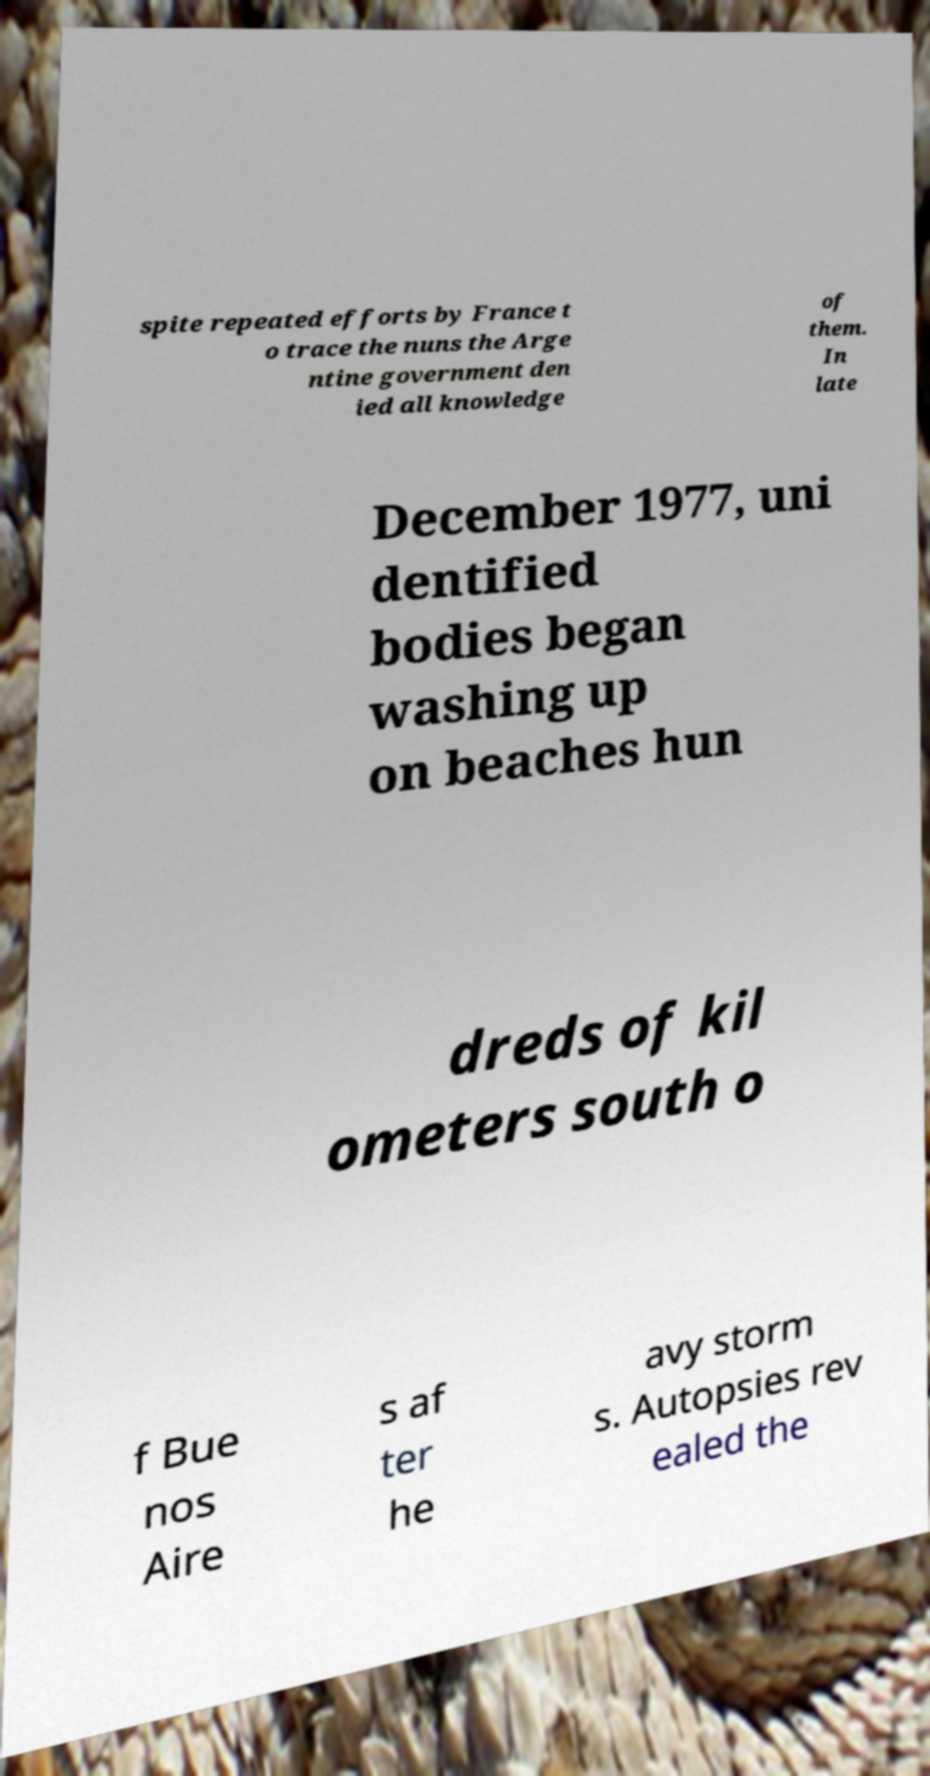For documentation purposes, I need the text within this image transcribed. Could you provide that? spite repeated efforts by France t o trace the nuns the Arge ntine government den ied all knowledge of them. In late December 1977, uni dentified bodies began washing up on beaches hun dreds of kil ometers south o f Bue nos Aire s af ter he avy storm s. Autopsies rev ealed the 